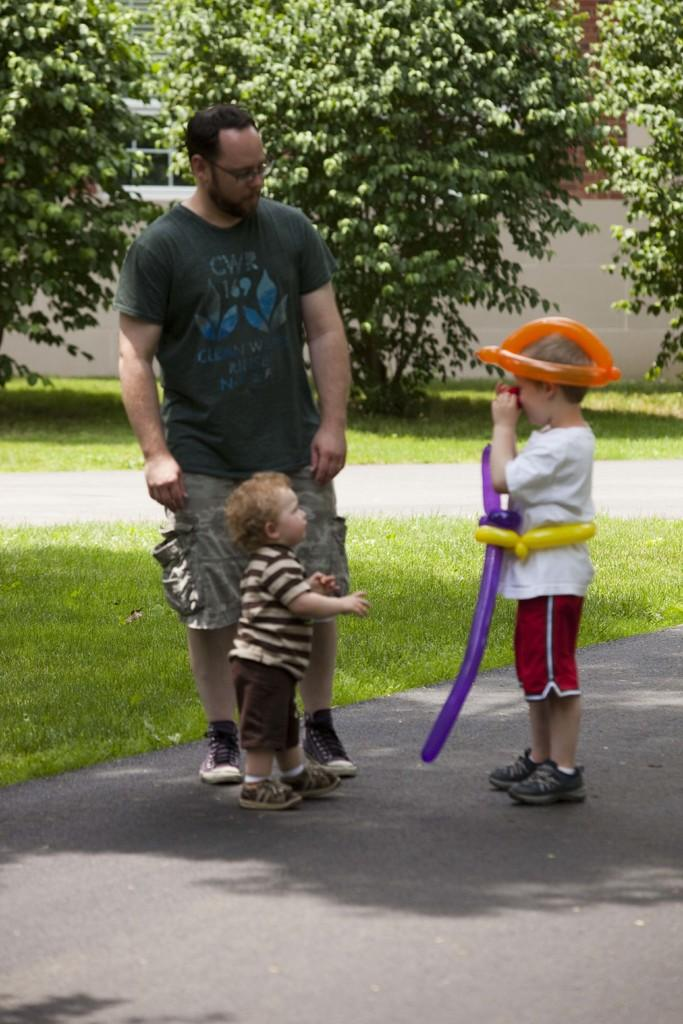Who is present in the image? There is a man and two kids in the image. What is the right side kid holding? The right side kid is holding balloons. What can be seen in the background of the image? There are trees, a fence, and grass in the background of the image. What type of brake can be seen on the sidewalk in the image? There is no sidewalk or brake present in the image. How does the man change the color of the balloons in the image? The man does not change the color of the balloons in the image; the right side kid is holding the balloons. 